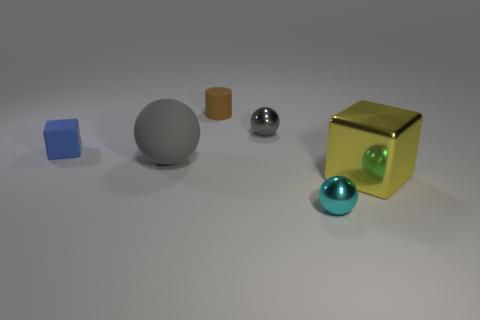There is a shiny ball behind the yellow metallic block; is its size the same as the tiny block?
Make the answer very short. Yes. Are there any other things that are the same size as the cyan metallic object?
Offer a very short reply. Yes. The other gray thing that is the same shape as the gray rubber object is what size?
Keep it short and to the point. Small. Are there the same number of shiny objects to the left of the yellow metallic block and gray metal objects left of the large gray object?
Offer a terse response. No. What is the size of the ball that is in front of the yellow shiny cube?
Provide a short and direct response. Small. Is the large ball the same color as the large block?
Provide a succinct answer. No. Are there any other things that have the same shape as the small blue rubber thing?
Offer a very short reply. Yes. There is another ball that is the same color as the big matte sphere; what is its material?
Offer a terse response. Metal. Are there the same number of cyan objects behind the cyan thing and purple rubber objects?
Offer a terse response. Yes. There is a metallic block; are there any things to the left of it?
Keep it short and to the point. Yes. 